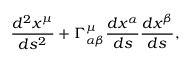Convert formula to latex. <formula><loc_0><loc_0><loc_500><loc_500>\frac { d ^ { 2 } x ^ { \mu } } { d s ^ { 2 } } + \Gamma _ { \alpha \beta } ^ { \mu } \frac { d x ^ { \alpha } } { d s } \frac { d x ^ { \beta } } { d s } ,</formula> 